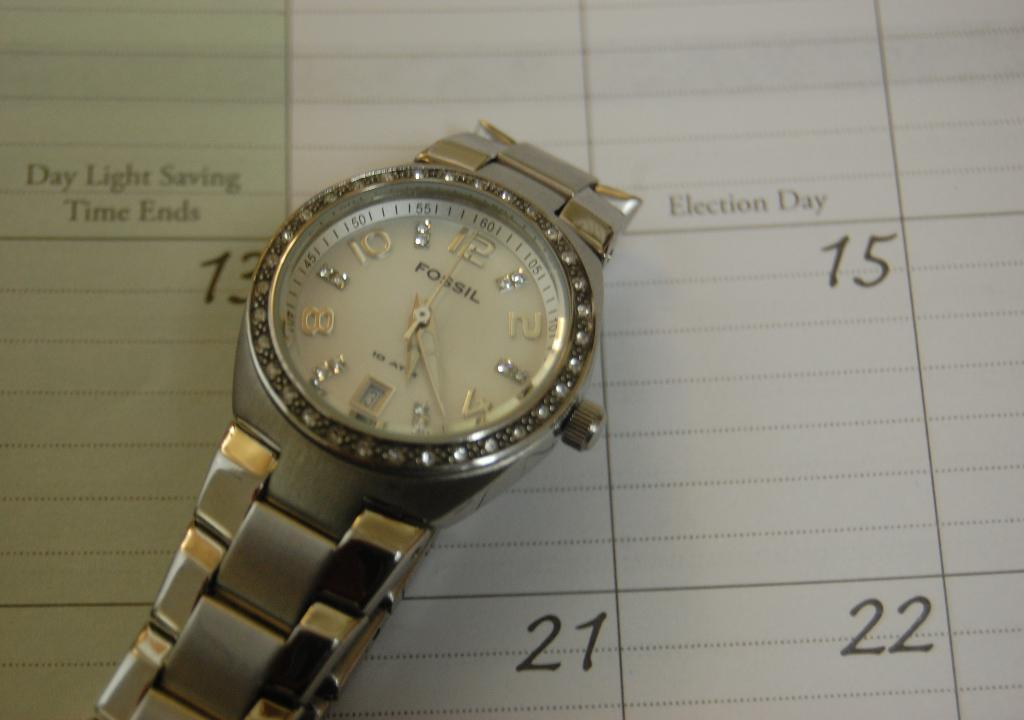<image>
Describe the image concisely. Fossil watch with diamonds and is the color silver. 